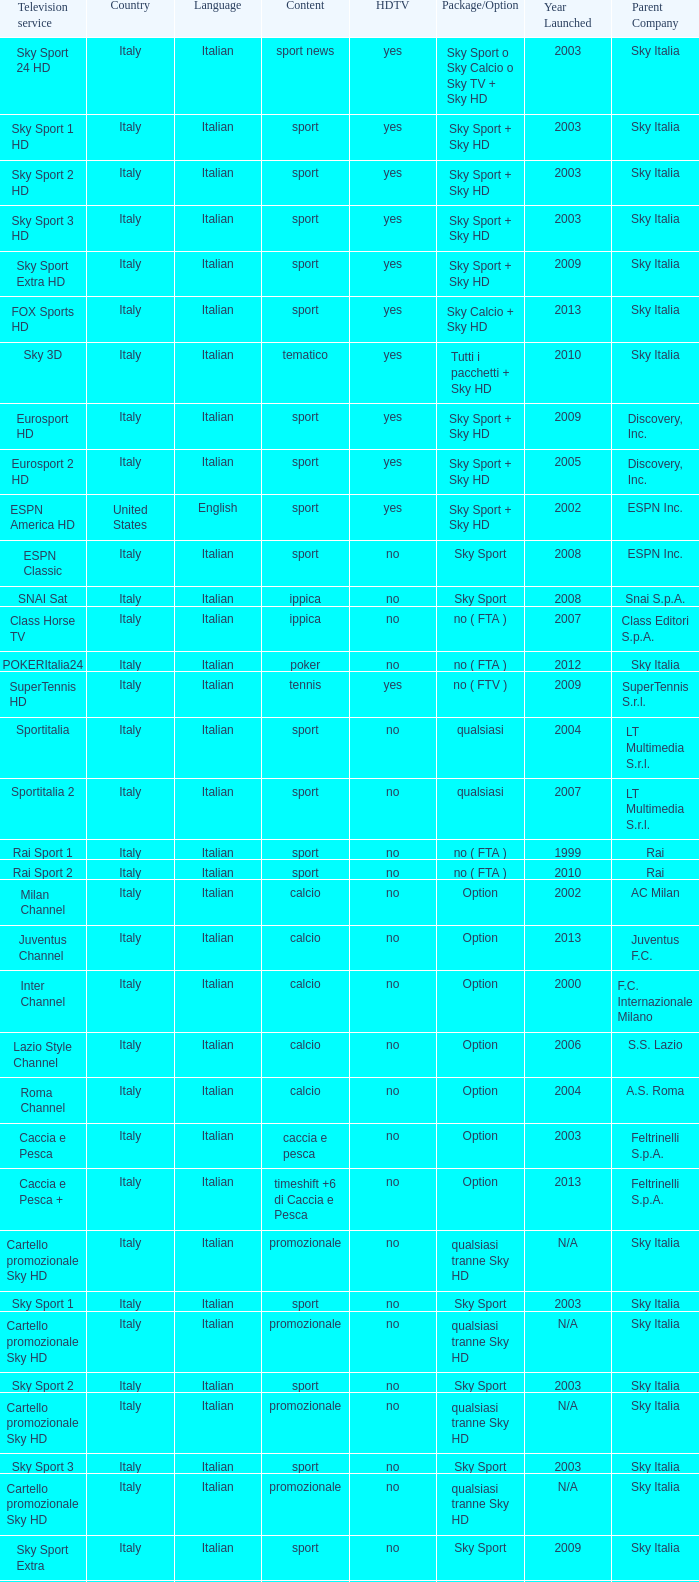What is Television Service, when Content is Calcio, and when Package/Option is Option? Milan Channel, Juventus Channel, Inter Channel, Lazio Style Channel, Roma Channel. 